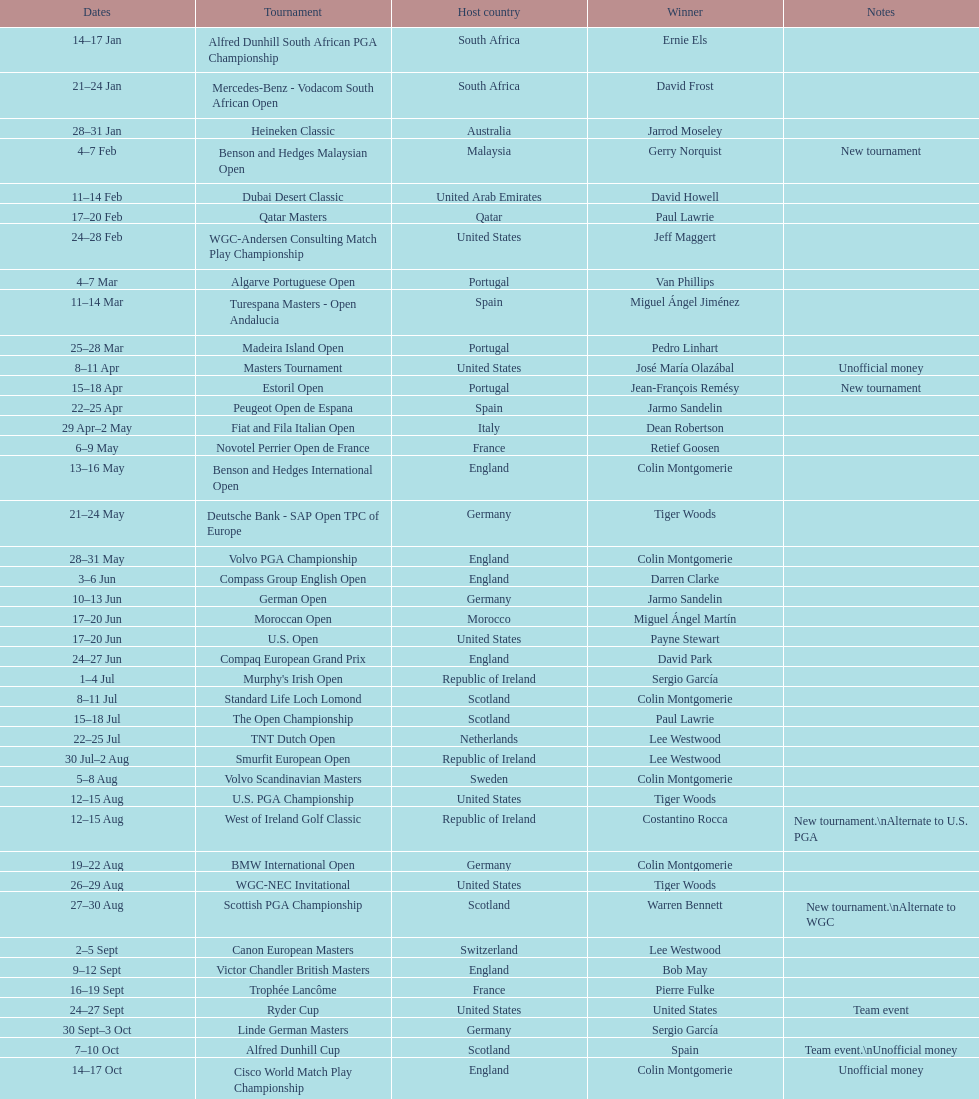What was the nation mentioned the first time a new competition emerged? Malaysia. 